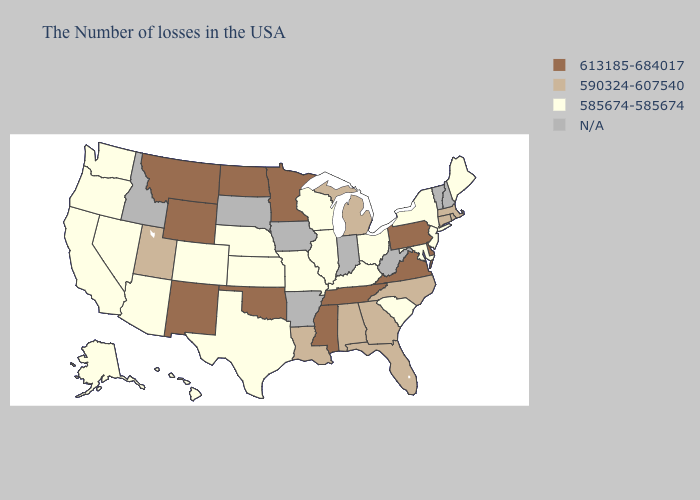Does Mississippi have the highest value in the USA?
Write a very short answer. Yes. Which states hav the highest value in the MidWest?
Quick response, please. Minnesota, North Dakota. Among the states that border Louisiana , does Texas have the highest value?
Keep it brief. No. What is the value of Indiana?
Short answer required. N/A. Does the first symbol in the legend represent the smallest category?
Keep it brief. No. Name the states that have a value in the range N/A?
Short answer required. New Hampshire, Vermont, West Virginia, Indiana, Arkansas, Iowa, South Dakota, Idaho. How many symbols are there in the legend?
Be succinct. 4. Name the states that have a value in the range 585674-585674?
Answer briefly. Maine, New York, New Jersey, Maryland, South Carolina, Ohio, Kentucky, Wisconsin, Illinois, Missouri, Kansas, Nebraska, Texas, Colorado, Arizona, Nevada, California, Washington, Oregon, Alaska, Hawaii. What is the value of Iowa?
Concise answer only. N/A. What is the highest value in the Northeast ?
Keep it brief. 613185-684017. Does Wyoming have the highest value in the USA?
Give a very brief answer. Yes. What is the value of West Virginia?
Quick response, please. N/A. Does South Carolina have the lowest value in the USA?
Keep it brief. Yes. Is the legend a continuous bar?
Write a very short answer. No. 